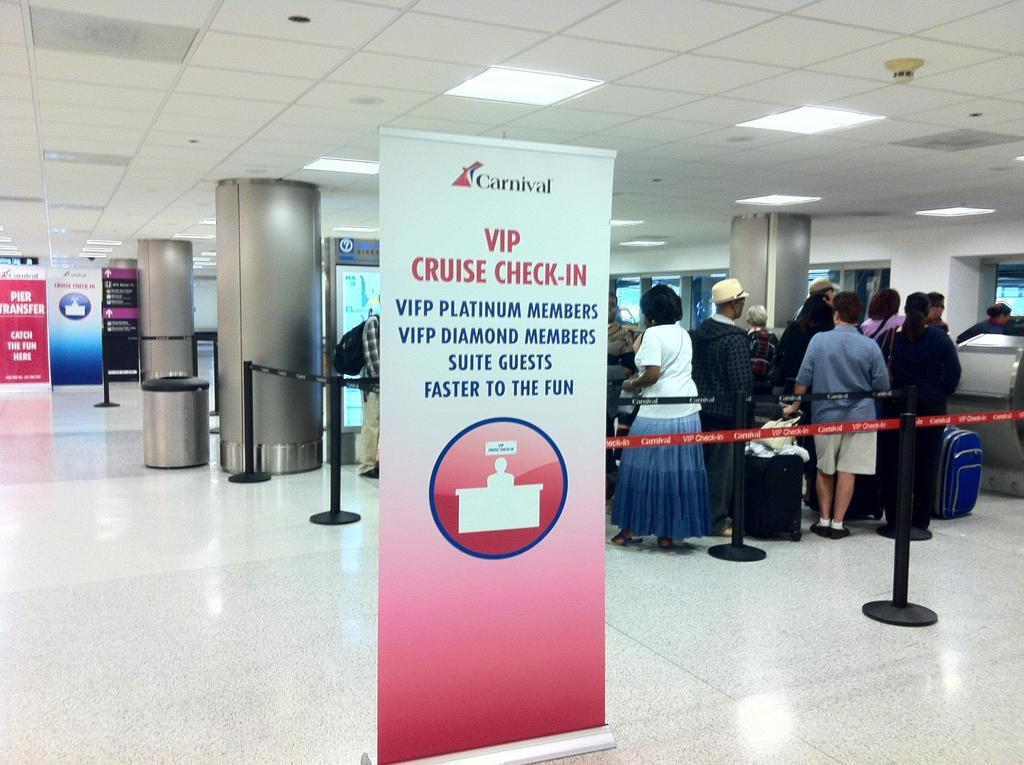What are the people in the image doing? The people in the image are standing within the boundary tape. What might suggest that the people are about to travel or have just arrived? The people have luggage with them, which suggests they are about to travel or have just arrived. What can be seen hanging in the image? There are banners in the image. What is present on the floor in the image? A dustbin is present on the floor. What can be seen on the roof in the image? There are lightings on the roof top. What type of prison is depicted in the image? There is no prison present in the image; it features people standing within a boundary tape with luggage, banners, a dustbin, and lightings. 